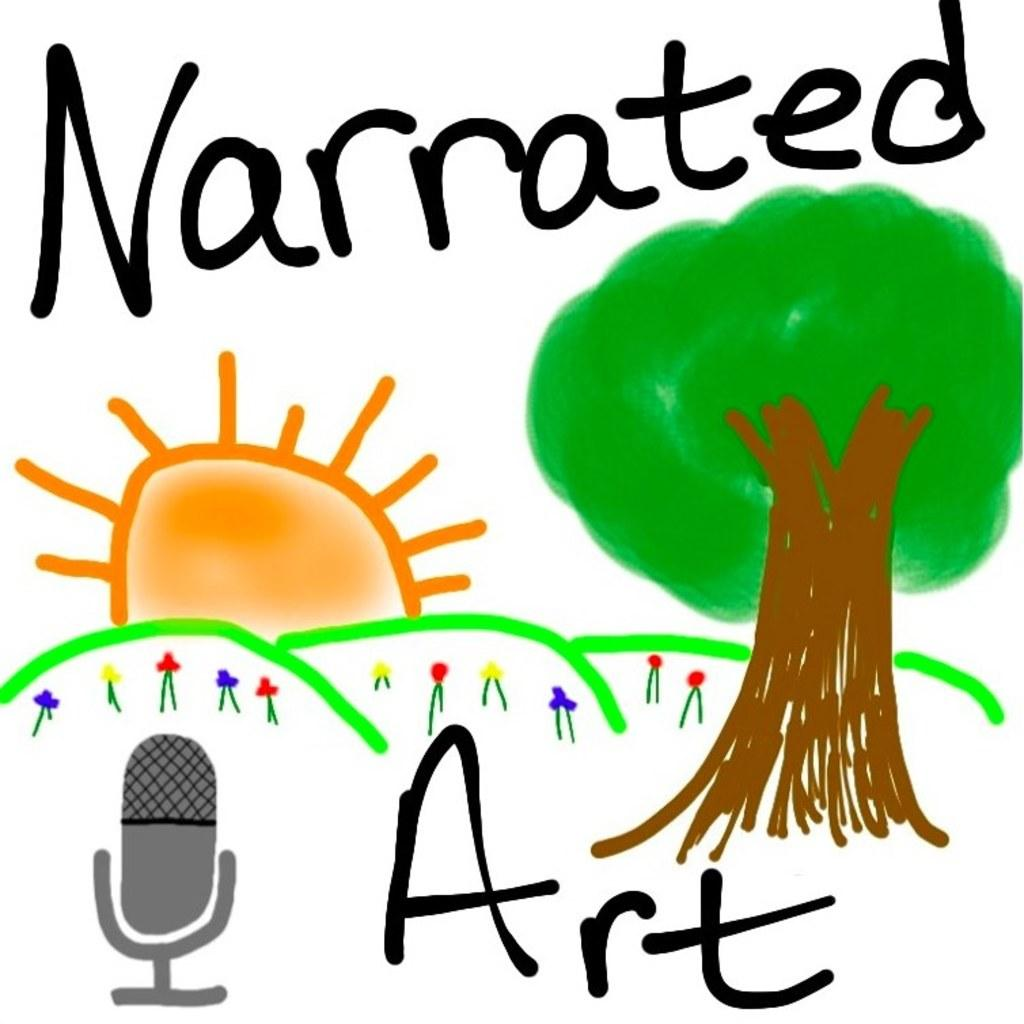What type of subject is featured in the image? The image contains an art piece. What elements are included in the art piece? The art piece includes plants, a tree, the sun, and some text. How many fangs can be seen on the tree in the image? There are no fangs present in the image; the art piece includes a tree, but it does not have any fangs. 